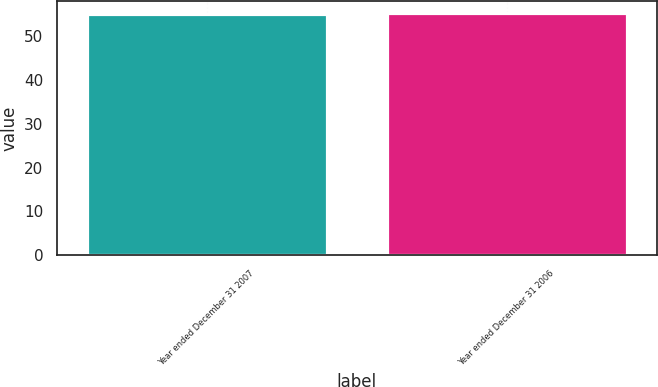<chart> <loc_0><loc_0><loc_500><loc_500><bar_chart><fcel>Year ended December 31 2007<fcel>Year ended December 31 2006<nl><fcel>55<fcel>55.1<nl></chart> 